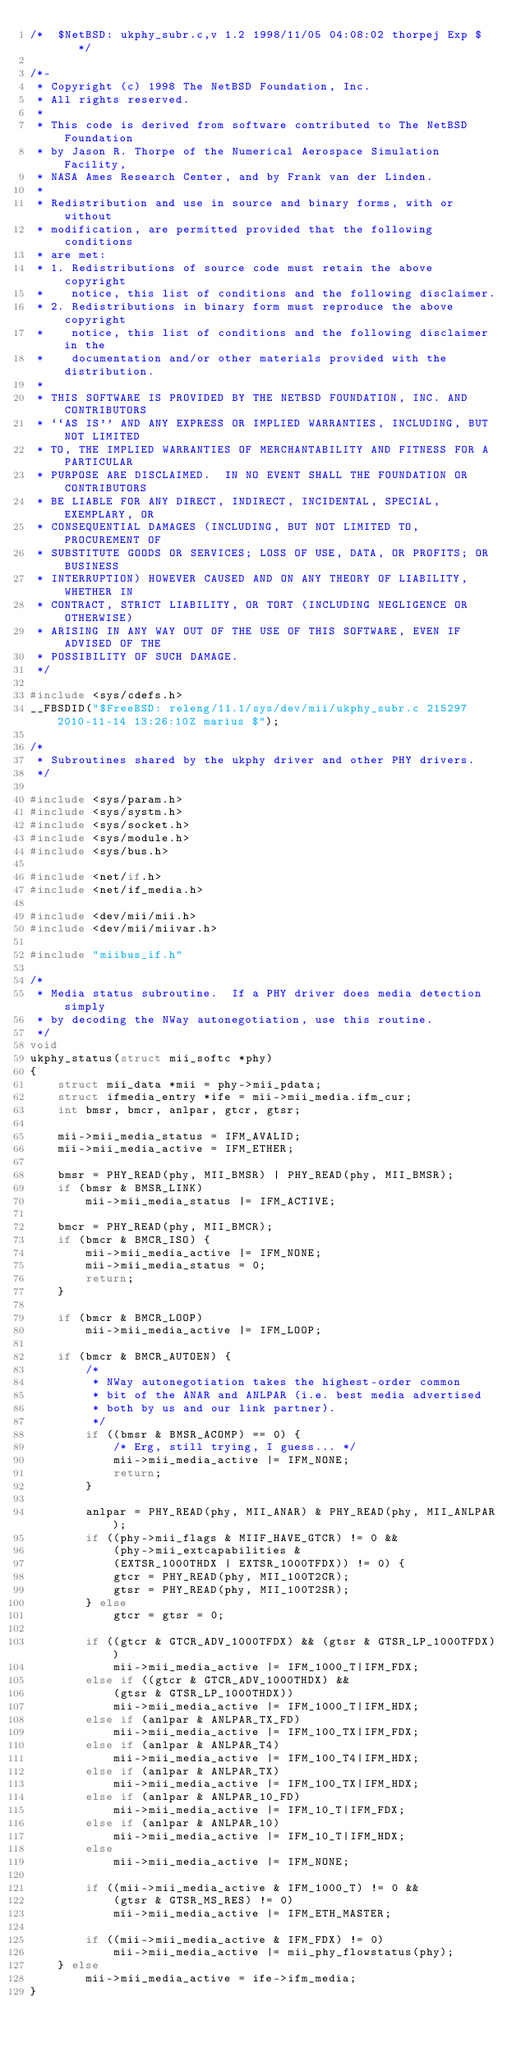Convert code to text. <code><loc_0><loc_0><loc_500><loc_500><_C_>/*	$NetBSD: ukphy_subr.c,v 1.2 1998/11/05 04:08:02 thorpej Exp $	*/

/*-
 * Copyright (c) 1998 The NetBSD Foundation, Inc.
 * All rights reserved.
 *
 * This code is derived from software contributed to The NetBSD Foundation
 * by Jason R. Thorpe of the Numerical Aerospace Simulation Facility,
 * NASA Ames Research Center, and by Frank van der Linden.
 *
 * Redistribution and use in source and binary forms, with or without
 * modification, are permitted provided that the following conditions
 * are met:
 * 1. Redistributions of source code must retain the above copyright
 *    notice, this list of conditions and the following disclaimer.
 * 2. Redistributions in binary form must reproduce the above copyright
 *    notice, this list of conditions and the following disclaimer in the
 *    documentation and/or other materials provided with the distribution.
 *
 * THIS SOFTWARE IS PROVIDED BY THE NETBSD FOUNDATION, INC. AND CONTRIBUTORS
 * ``AS IS'' AND ANY EXPRESS OR IMPLIED WARRANTIES, INCLUDING, BUT NOT LIMITED
 * TO, THE IMPLIED WARRANTIES OF MERCHANTABILITY AND FITNESS FOR A PARTICULAR
 * PURPOSE ARE DISCLAIMED.  IN NO EVENT SHALL THE FOUNDATION OR CONTRIBUTORS
 * BE LIABLE FOR ANY DIRECT, INDIRECT, INCIDENTAL, SPECIAL, EXEMPLARY, OR
 * CONSEQUENTIAL DAMAGES (INCLUDING, BUT NOT LIMITED TO, PROCUREMENT OF
 * SUBSTITUTE GOODS OR SERVICES; LOSS OF USE, DATA, OR PROFITS; OR BUSINESS
 * INTERRUPTION) HOWEVER CAUSED AND ON ANY THEORY OF LIABILITY, WHETHER IN
 * CONTRACT, STRICT LIABILITY, OR TORT (INCLUDING NEGLIGENCE OR OTHERWISE)
 * ARISING IN ANY WAY OUT OF THE USE OF THIS SOFTWARE, EVEN IF ADVISED OF THE
 * POSSIBILITY OF SUCH DAMAGE.
 */

#include <sys/cdefs.h>
__FBSDID("$FreeBSD: releng/11.1/sys/dev/mii/ukphy_subr.c 215297 2010-11-14 13:26:10Z marius $");

/*
 * Subroutines shared by the ukphy driver and other PHY drivers.
 */

#include <sys/param.h>
#include <sys/systm.h>
#include <sys/socket.h>
#include <sys/module.h>
#include <sys/bus.h>

#include <net/if.h>
#include <net/if_media.h>

#include <dev/mii/mii.h>
#include <dev/mii/miivar.h>

#include "miibus_if.h"

/*
 * Media status subroutine.  If a PHY driver does media detection simply
 * by decoding the NWay autonegotiation, use this routine.
 */
void
ukphy_status(struct mii_softc *phy)
{
	struct mii_data *mii = phy->mii_pdata;
	struct ifmedia_entry *ife = mii->mii_media.ifm_cur;
	int bmsr, bmcr, anlpar, gtcr, gtsr;

	mii->mii_media_status = IFM_AVALID;
	mii->mii_media_active = IFM_ETHER;

	bmsr = PHY_READ(phy, MII_BMSR) | PHY_READ(phy, MII_BMSR);
	if (bmsr & BMSR_LINK)
		mii->mii_media_status |= IFM_ACTIVE;

	bmcr = PHY_READ(phy, MII_BMCR);
	if (bmcr & BMCR_ISO) {
		mii->mii_media_active |= IFM_NONE;
		mii->mii_media_status = 0;
		return;
	}

	if (bmcr & BMCR_LOOP)
		mii->mii_media_active |= IFM_LOOP;

	if (bmcr & BMCR_AUTOEN) {
		/*
		 * NWay autonegotiation takes the highest-order common
		 * bit of the ANAR and ANLPAR (i.e. best media advertised
		 * both by us and our link partner).
		 */
		if ((bmsr & BMSR_ACOMP) == 0) {
			/* Erg, still trying, I guess... */
			mii->mii_media_active |= IFM_NONE;
			return;
		}

		anlpar = PHY_READ(phy, MII_ANAR) & PHY_READ(phy, MII_ANLPAR);
		if ((phy->mii_flags & MIIF_HAVE_GTCR) != 0 &&
		    (phy->mii_extcapabilities &
		    (EXTSR_1000THDX | EXTSR_1000TFDX)) != 0) {
			gtcr = PHY_READ(phy, MII_100T2CR);
			gtsr = PHY_READ(phy, MII_100T2SR);
		} else
			gtcr = gtsr = 0;

		if ((gtcr & GTCR_ADV_1000TFDX) && (gtsr & GTSR_LP_1000TFDX))
			mii->mii_media_active |= IFM_1000_T|IFM_FDX;
		else if ((gtcr & GTCR_ADV_1000THDX) &&
		    (gtsr & GTSR_LP_1000THDX))
			mii->mii_media_active |= IFM_1000_T|IFM_HDX;
		else if (anlpar & ANLPAR_TX_FD)
			mii->mii_media_active |= IFM_100_TX|IFM_FDX;
		else if (anlpar & ANLPAR_T4)
			mii->mii_media_active |= IFM_100_T4|IFM_HDX;
		else if (anlpar & ANLPAR_TX)
			mii->mii_media_active |= IFM_100_TX|IFM_HDX;
		else if (anlpar & ANLPAR_10_FD)
			mii->mii_media_active |= IFM_10_T|IFM_FDX;
		else if (anlpar & ANLPAR_10)
			mii->mii_media_active |= IFM_10_T|IFM_HDX;
		else
			mii->mii_media_active |= IFM_NONE;

		if ((mii->mii_media_active & IFM_1000_T) != 0 &&
		    (gtsr & GTSR_MS_RES) != 0)
			mii->mii_media_active |= IFM_ETH_MASTER;

		if ((mii->mii_media_active & IFM_FDX) != 0)
			mii->mii_media_active |= mii_phy_flowstatus(phy);
	} else
		mii->mii_media_active = ife->ifm_media;
}
</code> 